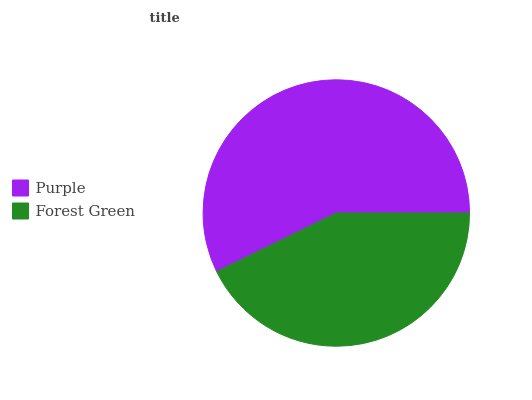Is Forest Green the minimum?
Answer yes or no. Yes. Is Purple the maximum?
Answer yes or no. Yes. Is Forest Green the maximum?
Answer yes or no. No. Is Purple greater than Forest Green?
Answer yes or no. Yes. Is Forest Green less than Purple?
Answer yes or no. Yes. Is Forest Green greater than Purple?
Answer yes or no. No. Is Purple less than Forest Green?
Answer yes or no. No. Is Purple the high median?
Answer yes or no. Yes. Is Forest Green the low median?
Answer yes or no. Yes. Is Forest Green the high median?
Answer yes or no. No. Is Purple the low median?
Answer yes or no. No. 